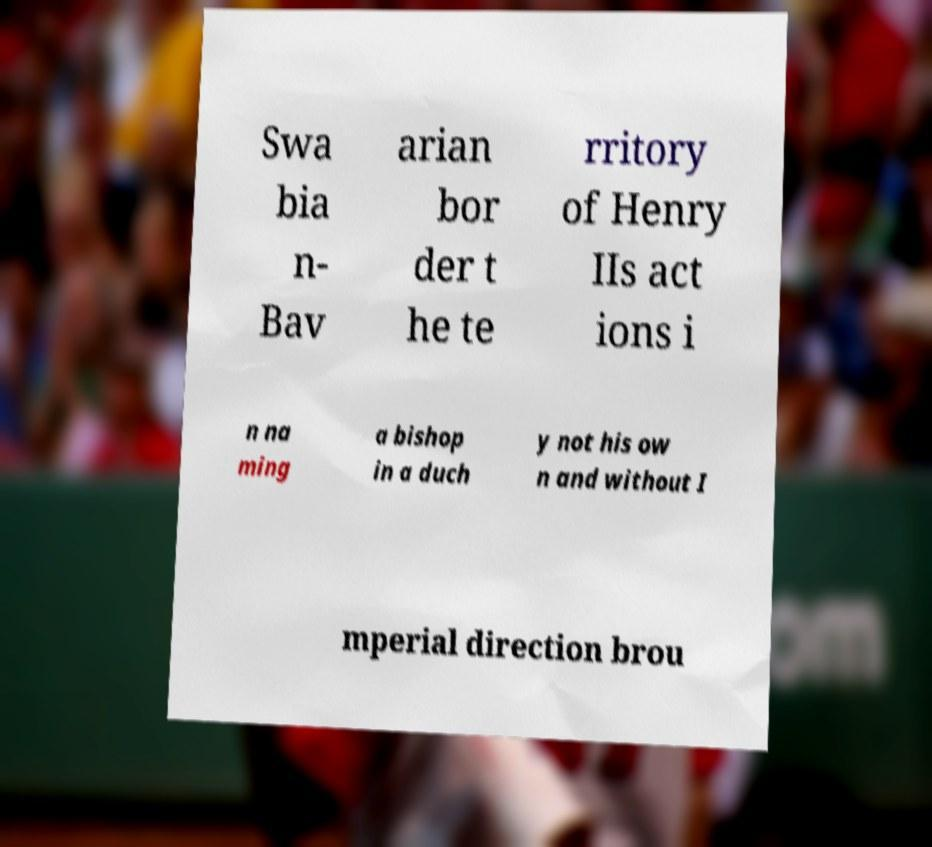Please identify and transcribe the text found in this image. Swa bia n- Bav arian bor der t he te rritory of Henry IIs act ions i n na ming a bishop in a duch y not his ow n and without I mperial direction brou 